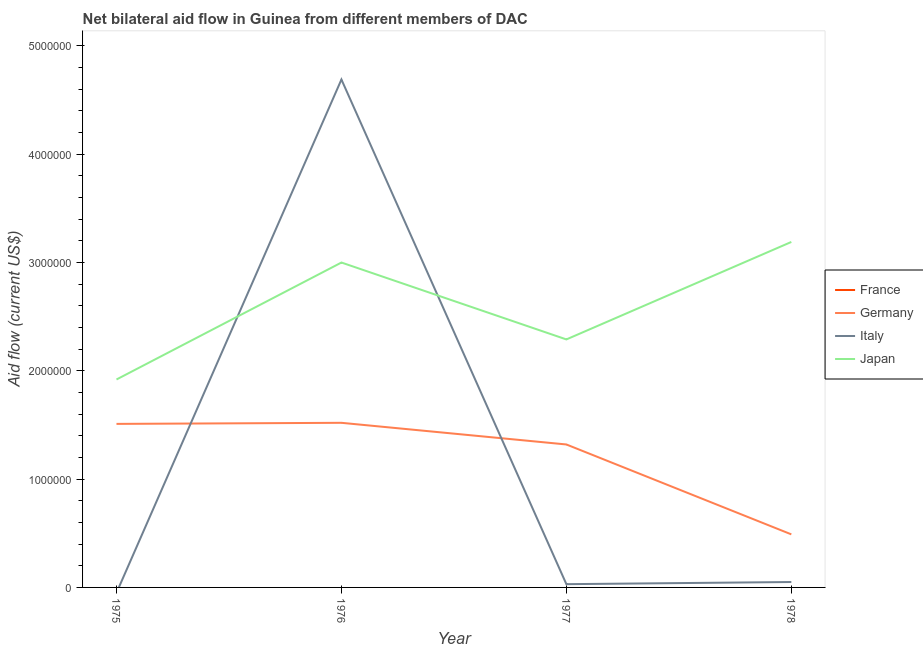How many different coloured lines are there?
Offer a very short reply. 3. Does the line corresponding to amount of aid given by italy intersect with the line corresponding to amount of aid given by france?
Offer a terse response. No. Is the number of lines equal to the number of legend labels?
Offer a very short reply. No. What is the amount of aid given by france in 1975?
Provide a succinct answer. 0. Across all years, what is the maximum amount of aid given by japan?
Provide a succinct answer. 3.19e+06. Across all years, what is the minimum amount of aid given by germany?
Ensure brevity in your answer.  4.90e+05. In which year was the amount of aid given by germany maximum?
Offer a terse response. 1976. What is the total amount of aid given by france in the graph?
Offer a very short reply. 0. What is the difference between the amount of aid given by germany in 1976 and that in 1977?
Your response must be concise. 2.00e+05. What is the difference between the amount of aid given by france in 1978 and the amount of aid given by germany in 1977?
Offer a terse response. -1.32e+06. What is the average amount of aid given by france per year?
Make the answer very short. 0. In the year 1976, what is the difference between the amount of aid given by japan and amount of aid given by italy?
Your response must be concise. -1.69e+06. What is the ratio of the amount of aid given by germany in 1976 to that in 1978?
Keep it short and to the point. 3.1. Is the difference between the amount of aid given by japan in 1977 and 1978 greater than the difference between the amount of aid given by germany in 1977 and 1978?
Provide a short and direct response. No. What is the difference between the highest and the second highest amount of aid given by italy?
Provide a short and direct response. 4.64e+06. What is the difference between the highest and the lowest amount of aid given by germany?
Give a very brief answer. 1.03e+06. In how many years, is the amount of aid given by italy greater than the average amount of aid given by italy taken over all years?
Offer a terse response. 1. Is the sum of the amount of aid given by japan in 1977 and 1978 greater than the maximum amount of aid given by france across all years?
Provide a succinct answer. Yes. Is it the case that in every year, the sum of the amount of aid given by japan and amount of aid given by france is greater than the sum of amount of aid given by germany and amount of aid given by italy?
Ensure brevity in your answer.  Yes. Is it the case that in every year, the sum of the amount of aid given by france and amount of aid given by germany is greater than the amount of aid given by italy?
Your answer should be very brief. No. Does the amount of aid given by italy monotonically increase over the years?
Ensure brevity in your answer.  No. Is the amount of aid given by germany strictly greater than the amount of aid given by japan over the years?
Your answer should be compact. No. How many lines are there?
Your response must be concise. 3. How many years are there in the graph?
Your answer should be compact. 4. Are the values on the major ticks of Y-axis written in scientific E-notation?
Make the answer very short. No. How many legend labels are there?
Ensure brevity in your answer.  4. What is the title of the graph?
Provide a short and direct response. Net bilateral aid flow in Guinea from different members of DAC. Does "CO2 damage" appear as one of the legend labels in the graph?
Your answer should be very brief. No. What is the label or title of the X-axis?
Provide a succinct answer. Year. What is the label or title of the Y-axis?
Offer a very short reply. Aid flow (current US$). What is the Aid flow (current US$) of Germany in 1975?
Make the answer very short. 1.51e+06. What is the Aid flow (current US$) of Italy in 1975?
Keep it short and to the point. 0. What is the Aid flow (current US$) of Japan in 1975?
Give a very brief answer. 1.92e+06. What is the Aid flow (current US$) of Germany in 1976?
Your response must be concise. 1.52e+06. What is the Aid flow (current US$) in Italy in 1976?
Provide a short and direct response. 4.69e+06. What is the Aid flow (current US$) in Japan in 1976?
Make the answer very short. 3.00e+06. What is the Aid flow (current US$) in Germany in 1977?
Your answer should be very brief. 1.32e+06. What is the Aid flow (current US$) in Japan in 1977?
Keep it short and to the point. 2.29e+06. What is the Aid flow (current US$) of Japan in 1978?
Give a very brief answer. 3.19e+06. Across all years, what is the maximum Aid flow (current US$) in Germany?
Keep it short and to the point. 1.52e+06. Across all years, what is the maximum Aid flow (current US$) in Italy?
Keep it short and to the point. 4.69e+06. Across all years, what is the maximum Aid flow (current US$) in Japan?
Ensure brevity in your answer.  3.19e+06. Across all years, what is the minimum Aid flow (current US$) in Italy?
Your response must be concise. 0. Across all years, what is the minimum Aid flow (current US$) in Japan?
Make the answer very short. 1.92e+06. What is the total Aid flow (current US$) in France in the graph?
Offer a terse response. 0. What is the total Aid flow (current US$) of Germany in the graph?
Your answer should be compact. 4.84e+06. What is the total Aid flow (current US$) in Italy in the graph?
Ensure brevity in your answer.  4.77e+06. What is the total Aid flow (current US$) in Japan in the graph?
Keep it short and to the point. 1.04e+07. What is the difference between the Aid flow (current US$) of Germany in 1975 and that in 1976?
Offer a very short reply. -10000. What is the difference between the Aid flow (current US$) in Japan in 1975 and that in 1976?
Offer a terse response. -1.08e+06. What is the difference between the Aid flow (current US$) of Japan in 1975 and that in 1977?
Your answer should be very brief. -3.70e+05. What is the difference between the Aid flow (current US$) in Germany in 1975 and that in 1978?
Keep it short and to the point. 1.02e+06. What is the difference between the Aid flow (current US$) in Japan in 1975 and that in 1978?
Offer a very short reply. -1.27e+06. What is the difference between the Aid flow (current US$) in Italy in 1976 and that in 1977?
Your answer should be compact. 4.66e+06. What is the difference between the Aid flow (current US$) of Japan in 1976 and that in 1977?
Your answer should be very brief. 7.10e+05. What is the difference between the Aid flow (current US$) in Germany in 1976 and that in 1978?
Offer a terse response. 1.03e+06. What is the difference between the Aid flow (current US$) in Italy in 1976 and that in 1978?
Your answer should be very brief. 4.64e+06. What is the difference between the Aid flow (current US$) of Japan in 1976 and that in 1978?
Provide a succinct answer. -1.90e+05. What is the difference between the Aid flow (current US$) in Germany in 1977 and that in 1978?
Your answer should be compact. 8.30e+05. What is the difference between the Aid flow (current US$) of Italy in 1977 and that in 1978?
Provide a succinct answer. -2.00e+04. What is the difference between the Aid flow (current US$) of Japan in 1977 and that in 1978?
Your answer should be very brief. -9.00e+05. What is the difference between the Aid flow (current US$) of Germany in 1975 and the Aid flow (current US$) of Italy in 1976?
Your answer should be very brief. -3.18e+06. What is the difference between the Aid flow (current US$) of Germany in 1975 and the Aid flow (current US$) of Japan in 1976?
Ensure brevity in your answer.  -1.49e+06. What is the difference between the Aid flow (current US$) in Germany in 1975 and the Aid flow (current US$) in Italy in 1977?
Offer a terse response. 1.48e+06. What is the difference between the Aid flow (current US$) of Germany in 1975 and the Aid flow (current US$) of Japan in 1977?
Offer a terse response. -7.80e+05. What is the difference between the Aid flow (current US$) in Germany in 1975 and the Aid flow (current US$) in Italy in 1978?
Your answer should be compact. 1.46e+06. What is the difference between the Aid flow (current US$) in Germany in 1975 and the Aid flow (current US$) in Japan in 1978?
Your response must be concise. -1.68e+06. What is the difference between the Aid flow (current US$) in Germany in 1976 and the Aid flow (current US$) in Italy in 1977?
Your answer should be compact. 1.49e+06. What is the difference between the Aid flow (current US$) of Germany in 1976 and the Aid flow (current US$) of Japan in 1977?
Your response must be concise. -7.70e+05. What is the difference between the Aid flow (current US$) of Italy in 1976 and the Aid flow (current US$) of Japan in 1977?
Offer a very short reply. 2.40e+06. What is the difference between the Aid flow (current US$) in Germany in 1976 and the Aid flow (current US$) in Italy in 1978?
Offer a very short reply. 1.47e+06. What is the difference between the Aid flow (current US$) of Germany in 1976 and the Aid flow (current US$) of Japan in 1978?
Make the answer very short. -1.67e+06. What is the difference between the Aid flow (current US$) of Italy in 1976 and the Aid flow (current US$) of Japan in 1978?
Provide a succinct answer. 1.50e+06. What is the difference between the Aid flow (current US$) in Germany in 1977 and the Aid flow (current US$) in Italy in 1978?
Make the answer very short. 1.27e+06. What is the difference between the Aid flow (current US$) of Germany in 1977 and the Aid flow (current US$) of Japan in 1978?
Give a very brief answer. -1.87e+06. What is the difference between the Aid flow (current US$) of Italy in 1977 and the Aid flow (current US$) of Japan in 1978?
Ensure brevity in your answer.  -3.16e+06. What is the average Aid flow (current US$) of Germany per year?
Your answer should be compact. 1.21e+06. What is the average Aid flow (current US$) of Italy per year?
Offer a very short reply. 1.19e+06. What is the average Aid flow (current US$) of Japan per year?
Ensure brevity in your answer.  2.60e+06. In the year 1975, what is the difference between the Aid flow (current US$) of Germany and Aid flow (current US$) of Japan?
Provide a succinct answer. -4.10e+05. In the year 1976, what is the difference between the Aid flow (current US$) in Germany and Aid flow (current US$) in Italy?
Offer a terse response. -3.17e+06. In the year 1976, what is the difference between the Aid flow (current US$) in Germany and Aid flow (current US$) in Japan?
Ensure brevity in your answer.  -1.48e+06. In the year 1976, what is the difference between the Aid flow (current US$) in Italy and Aid flow (current US$) in Japan?
Offer a terse response. 1.69e+06. In the year 1977, what is the difference between the Aid flow (current US$) of Germany and Aid flow (current US$) of Italy?
Provide a succinct answer. 1.29e+06. In the year 1977, what is the difference between the Aid flow (current US$) in Germany and Aid flow (current US$) in Japan?
Your answer should be compact. -9.70e+05. In the year 1977, what is the difference between the Aid flow (current US$) in Italy and Aid flow (current US$) in Japan?
Keep it short and to the point. -2.26e+06. In the year 1978, what is the difference between the Aid flow (current US$) in Germany and Aid flow (current US$) in Japan?
Provide a succinct answer. -2.70e+06. In the year 1978, what is the difference between the Aid flow (current US$) in Italy and Aid flow (current US$) in Japan?
Your answer should be compact. -3.14e+06. What is the ratio of the Aid flow (current US$) of Germany in 1975 to that in 1976?
Your response must be concise. 0.99. What is the ratio of the Aid flow (current US$) of Japan in 1975 to that in 1976?
Provide a succinct answer. 0.64. What is the ratio of the Aid flow (current US$) in Germany in 1975 to that in 1977?
Make the answer very short. 1.14. What is the ratio of the Aid flow (current US$) in Japan in 1975 to that in 1977?
Give a very brief answer. 0.84. What is the ratio of the Aid flow (current US$) in Germany in 1975 to that in 1978?
Provide a short and direct response. 3.08. What is the ratio of the Aid flow (current US$) in Japan in 1975 to that in 1978?
Offer a terse response. 0.6. What is the ratio of the Aid flow (current US$) of Germany in 1976 to that in 1977?
Make the answer very short. 1.15. What is the ratio of the Aid flow (current US$) in Italy in 1976 to that in 1977?
Offer a very short reply. 156.33. What is the ratio of the Aid flow (current US$) of Japan in 1976 to that in 1977?
Offer a terse response. 1.31. What is the ratio of the Aid flow (current US$) of Germany in 1976 to that in 1978?
Your answer should be compact. 3.1. What is the ratio of the Aid flow (current US$) of Italy in 1976 to that in 1978?
Your response must be concise. 93.8. What is the ratio of the Aid flow (current US$) of Japan in 1976 to that in 1978?
Make the answer very short. 0.94. What is the ratio of the Aid flow (current US$) of Germany in 1977 to that in 1978?
Keep it short and to the point. 2.69. What is the ratio of the Aid flow (current US$) in Italy in 1977 to that in 1978?
Keep it short and to the point. 0.6. What is the ratio of the Aid flow (current US$) in Japan in 1977 to that in 1978?
Your answer should be very brief. 0.72. What is the difference between the highest and the second highest Aid flow (current US$) of Germany?
Provide a succinct answer. 10000. What is the difference between the highest and the second highest Aid flow (current US$) in Italy?
Your answer should be very brief. 4.64e+06. What is the difference between the highest and the second highest Aid flow (current US$) of Japan?
Provide a succinct answer. 1.90e+05. What is the difference between the highest and the lowest Aid flow (current US$) in Germany?
Your answer should be very brief. 1.03e+06. What is the difference between the highest and the lowest Aid flow (current US$) in Italy?
Your response must be concise. 4.69e+06. What is the difference between the highest and the lowest Aid flow (current US$) in Japan?
Make the answer very short. 1.27e+06. 